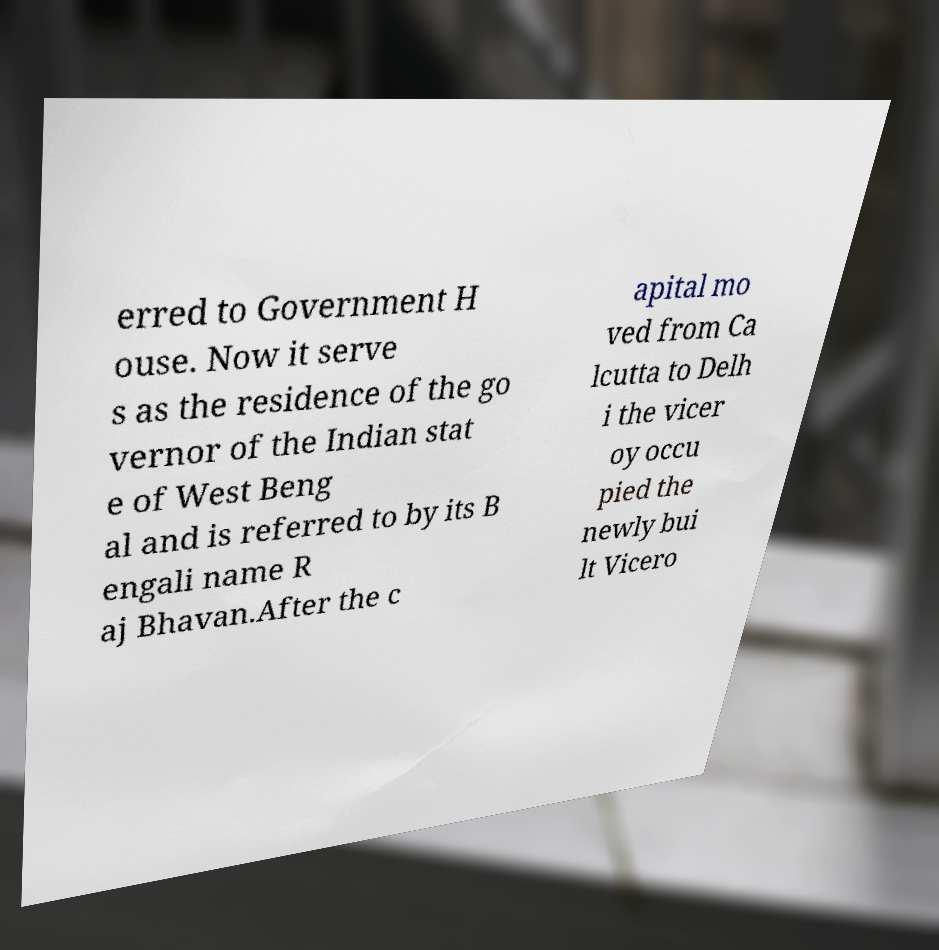For documentation purposes, I need the text within this image transcribed. Could you provide that? erred to Government H ouse. Now it serve s as the residence of the go vernor of the Indian stat e of West Beng al and is referred to by its B engali name R aj Bhavan.After the c apital mo ved from Ca lcutta to Delh i the vicer oy occu pied the newly bui lt Vicero 